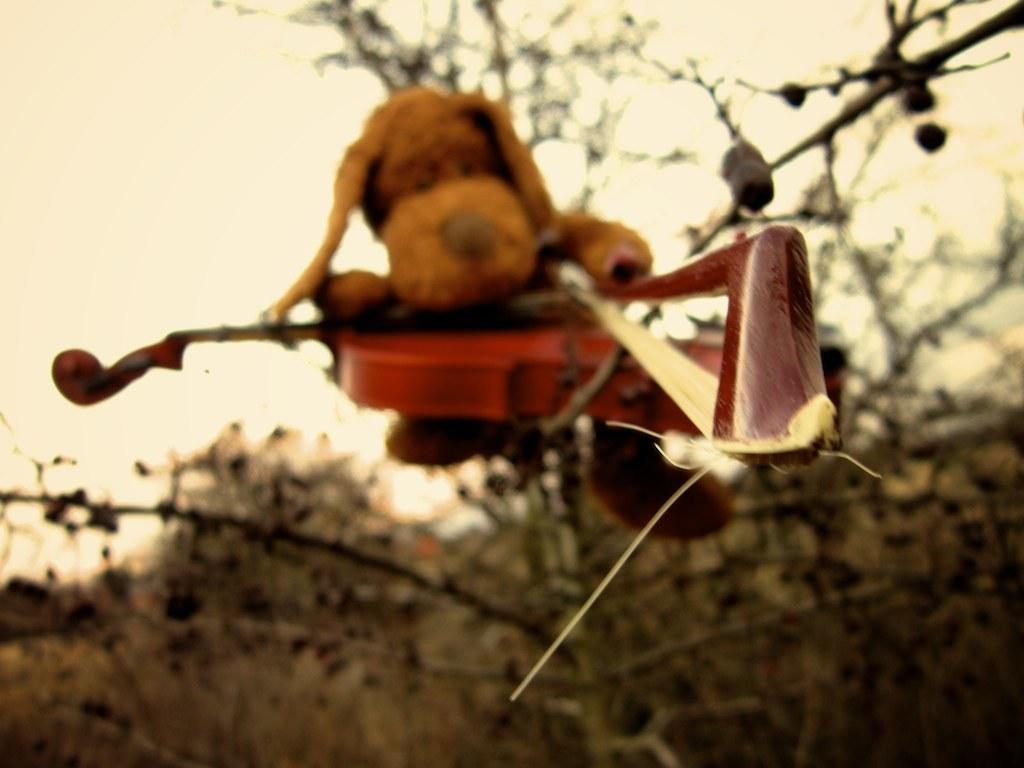What objects are in the foreground of the image? There is a toy and a guitar in the foreground of the image. Where are the toy and guitar located? Both the toy and guitar are on a tree. What can be seen in the background of the image? There are trees and the sky visible in the background of the image. Where is the bucket of meat hanging from in the image? There is no bucket or meat present in the image. 